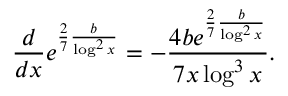Convert formula to latex. <formula><loc_0><loc_0><loc_500><loc_500>\frac { d } { d x } e ^ { \frac { 2 } { 7 } \frac { b } { \log ^ { 2 } x } } = - \frac { 4 b e ^ { \frac { 2 } { 7 } \frac { b } { \log ^ { 2 } x } } } { 7 x \log ^ { 3 } x } .</formula> 